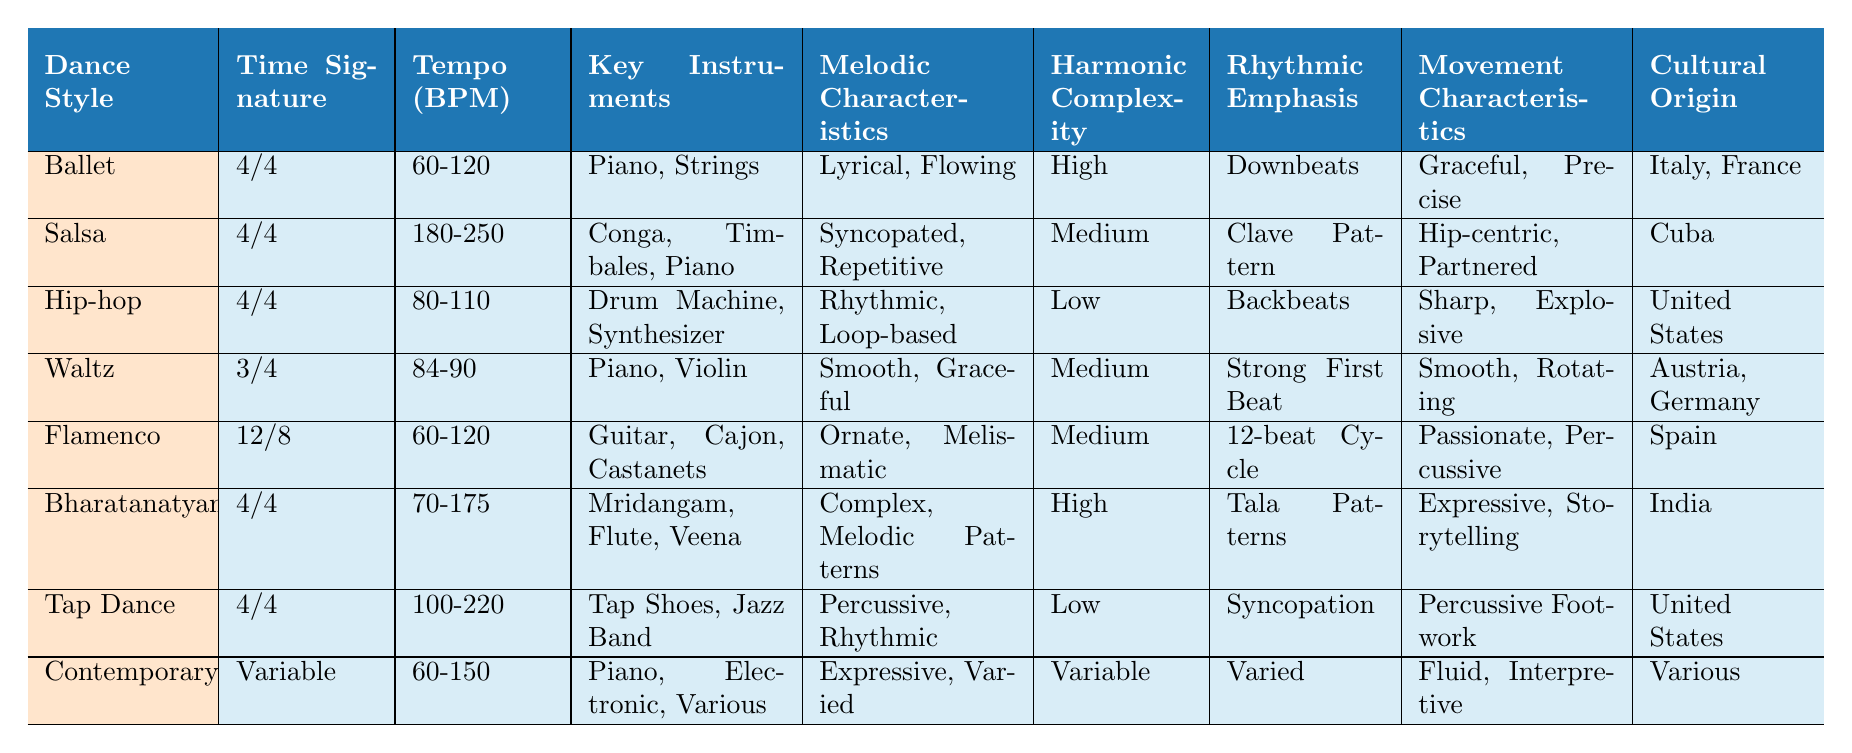What is the predominant time signature for Ballet? The table shows "4/4" under the "Predominant Time Signature" column for Ballet.
Answer: 4/4 Which dance style has the highest typical tempo range? The typical tempo for Salsa is listed as "180-250 BPM," which is higher than the others.
Answer: Salsa Is Flamenco characterized by a high harmonic complexity? Flamenco's harmonic complexity is rated as "Medium," which is not high.
Answer: No What are the key musical instruments used in Bharatanatyam? The table states that the key instruments for Bharatanatyam are "Mridangam, Flute, Veena."
Answer: Mridangam, Flute, Veena How many dance styles have a predominant time signature of 4/4? Ballet, Salsa, Hip-hop, Bharatanatyam, Tap Dance, and Contemporary have a 4/4 time signature. This totals to 6 styles.
Answer: 6 Which dance style has a variable predominant time signature? The table specifies that Contemporary has a "Variable" time signature.
Answer: Contemporary What is the tempo range for Tap Dance? The tempo range for Tap Dance is noted as "100-220 BPM."
Answer: 100-220 BPM Which dance style's cultural origin is India? According to the table, Bharatanatyam is the dance style with its cultural origin in India.
Answer: Bharatanatyam What melodic characteristic is associated with Salsa? The melodic characteristic for Salsa is described as "Syncopated, Repetitive."
Answer: Syncopated, Repetitive Compare the harmonic complexity between Waltz and Hip-hop. Waltz has "Medium" harmonic complexity, while Hip-hop is rated as "Low," indicating that Hip-hop is simpler.
Answer: Waltz: Medium, Hip-hop: Low Which dance styles feature percussive movement characteristics? The table lists Tap Dance and Flamenco as having percussive movement characteristics.
Answer: Tap Dance and Flamenco What is the typical tempo range for Contemporary dance? The typical tempo for Contemporary is listed as "60-150 BPM."
Answer: 60-150 BPM Which dance style has the smoothest melodic characteristics? The table indicates that Waltz has "Smooth, Graceful" melodic characteristics.
Answer: Waltz What rhythmic emphasis is used in Bharatanatyam? Bharatanatyam emphasizes "Tala Patterns" as its rhythmic feature.
Answer: Tala Patterns Is the rhythmic emphasis in Hip-hop based on backbeats? Yes, the rhythmic emphasis in Hip-hop is identified as "Backbeats."
Answer: Yes Identify the dance style associated with the instruments "Guitar, Cajon, Castanets." These instruments are associated with the dance style Flamenco.
Answer: Flamenco Which dance style has the most complex harmonic structure? Bharatanatyam is rated with "High" harmonic complexity, the highest in the table.
Answer: Bharatanatyam 